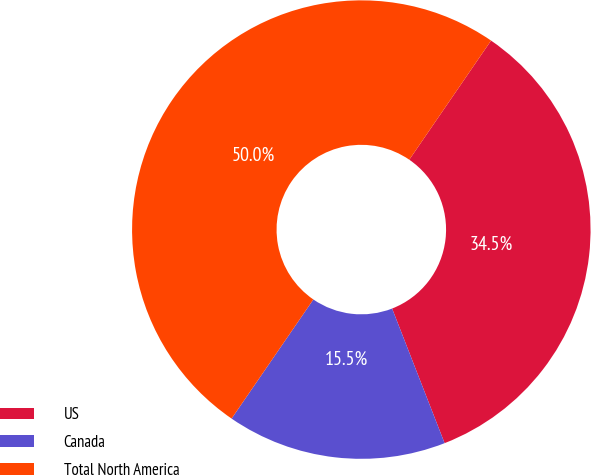Convert chart to OTSL. <chart><loc_0><loc_0><loc_500><loc_500><pie_chart><fcel>US<fcel>Canada<fcel>Total North America<nl><fcel>34.51%<fcel>15.49%<fcel>50.0%<nl></chart> 